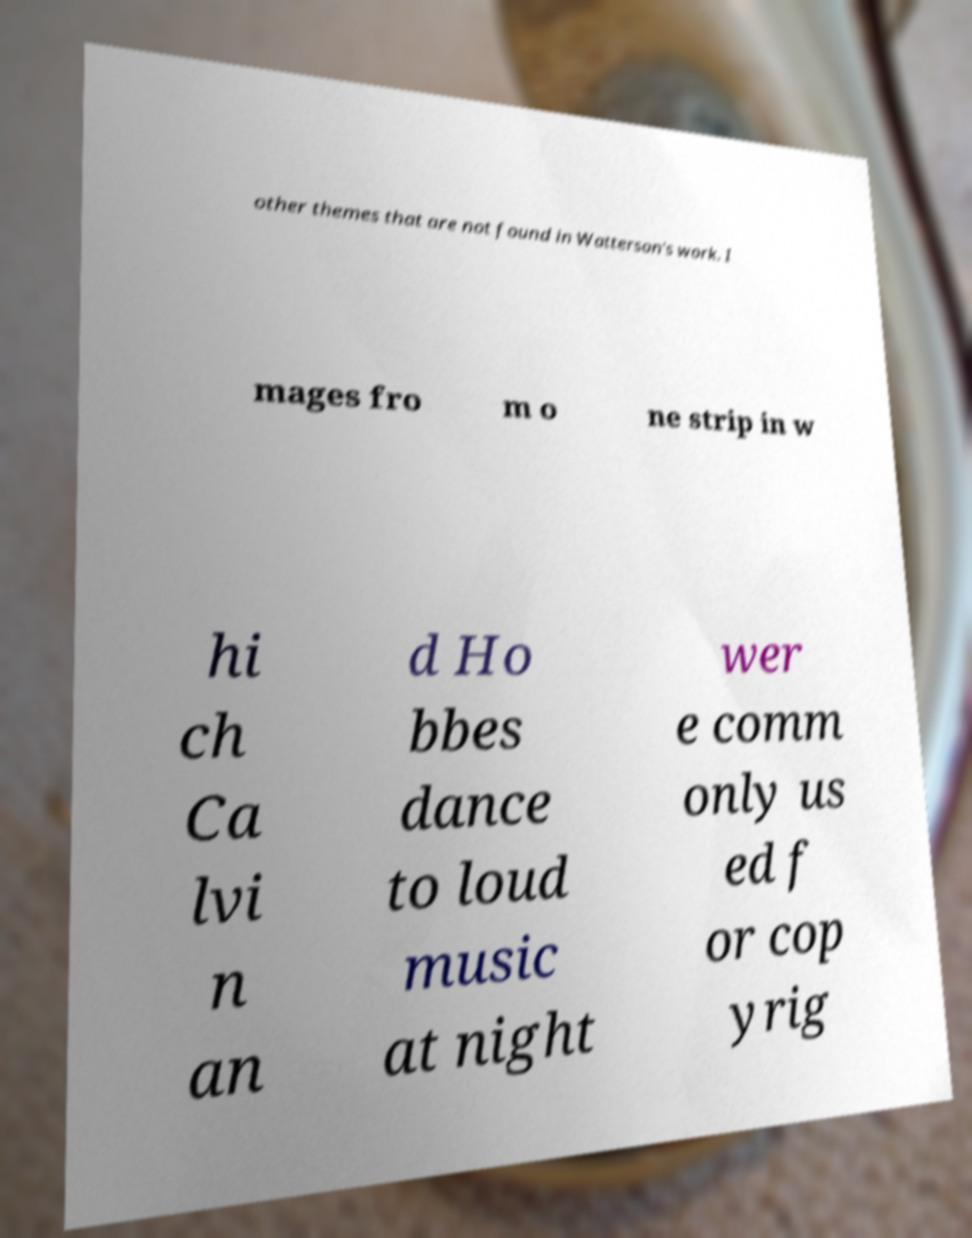Can you read and provide the text displayed in the image?This photo seems to have some interesting text. Can you extract and type it out for me? other themes that are not found in Watterson's work. I mages fro m o ne strip in w hi ch Ca lvi n an d Ho bbes dance to loud music at night wer e comm only us ed f or cop yrig 